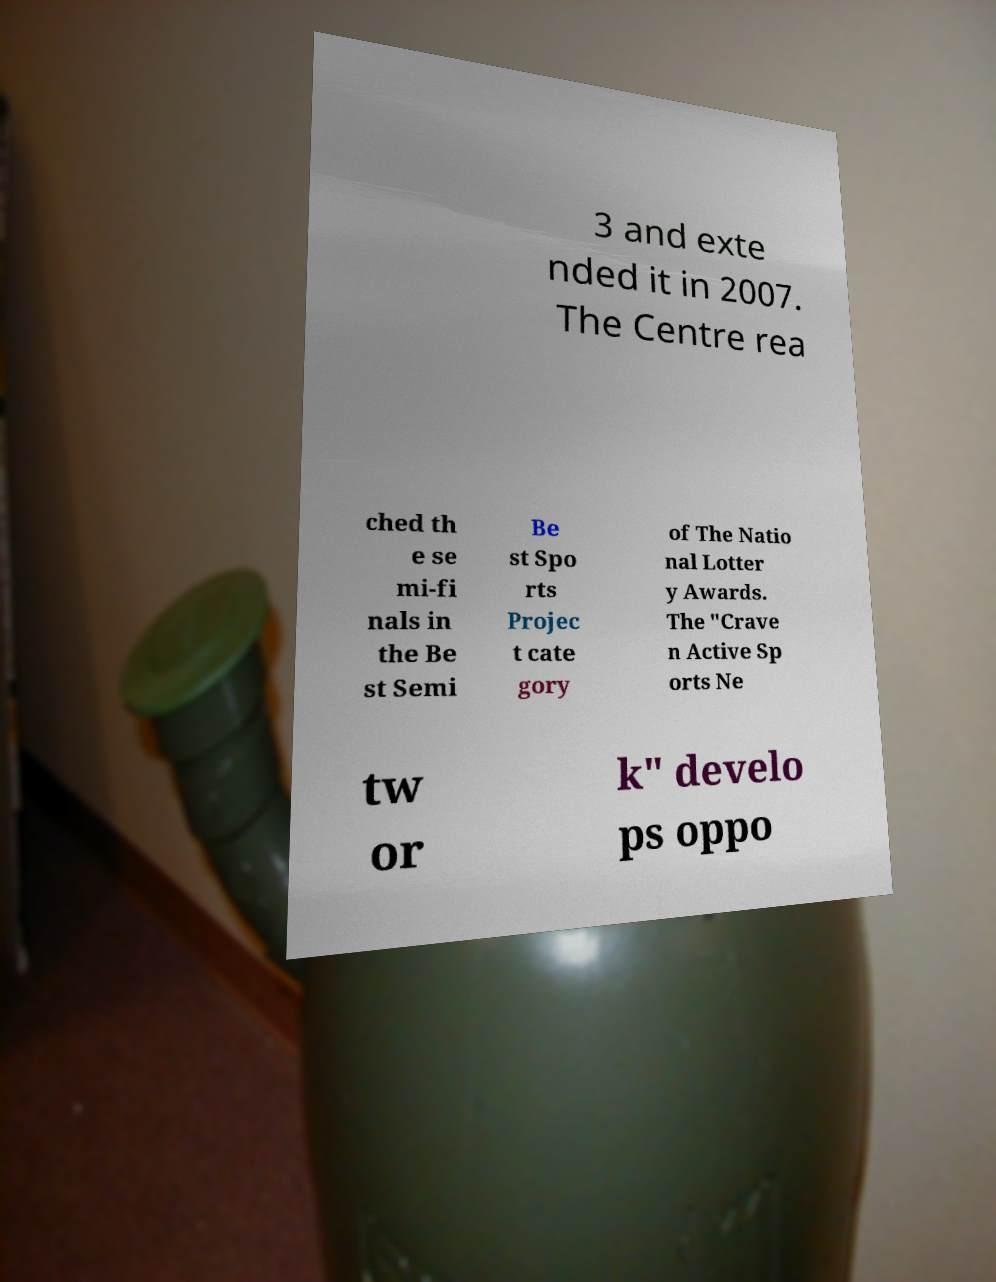Can you accurately transcribe the text from the provided image for me? 3 and exte nded it in 2007. The Centre rea ched th e se mi-fi nals in the Be st Semi Be st Spo rts Projec t cate gory of The Natio nal Lotter y Awards. The "Crave n Active Sp orts Ne tw or k" develo ps oppo 